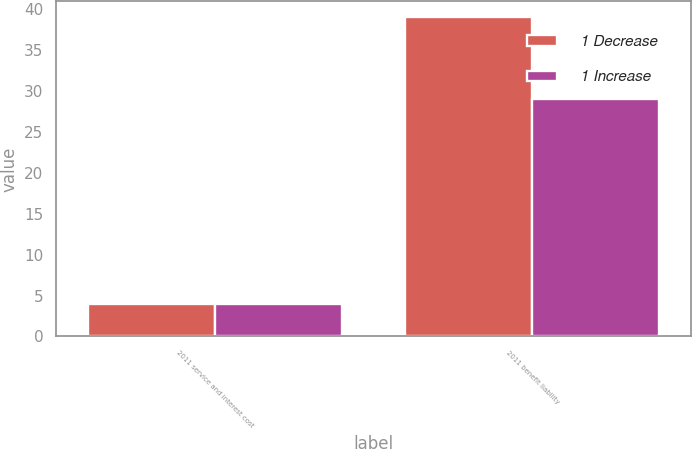Convert chart to OTSL. <chart><loc_0><loc_0><loc_500><loc_500><stacked_bar_chart><ecel><fcel>2011 service and interest cost<fcel>2011 benefit liability<nl><fcel>1 Decrease<fcel>4<fcel>39<nl><fcel>1 Increase<fcel>4<fcel>29<nl></chart> 